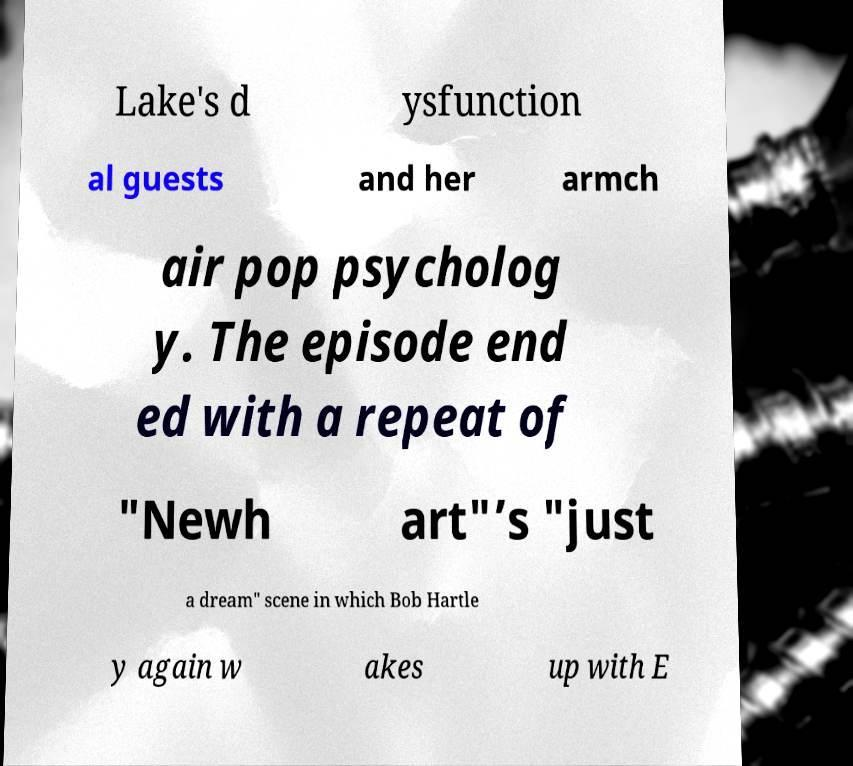Could you assist in decoding the text presented in this image and type it out clearly? Lake's d ysfunction al guests and her armch air pop psycholog y. The episode end ed with a repeat of "Newh art"’s "just a dream" scene in which Bob Hartle y again w akes up with E 